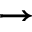Convert formula to latex. <formula><loc_0><loc_0><loc_500><loc_500>\rightarrow</formula> 